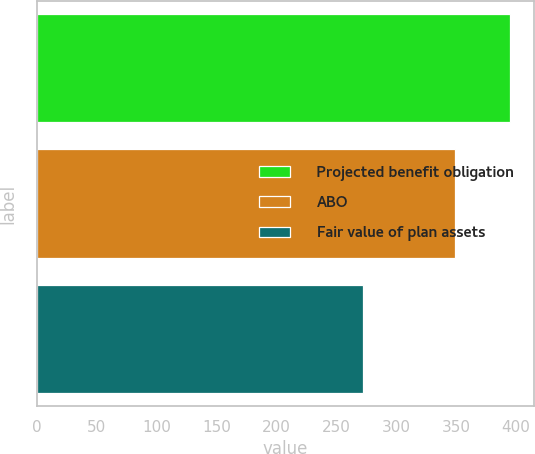Convert chart to OTSL. <chart><loc_0><loc_0><loc_500><loc_500><bar_chart><fcel>Projected benefit obligation<fcel>ABO<fcel>Fair value of plan assets<nl><fcel>395.4<fcel>349<fcel>272.7<nl></chart> 